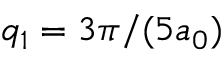Convert formula to latex. <formula><loc_0><loc_0><loc_500><loc_500>q _ { 1 } = 3 \pi / ( 5 a _ { 0 } )</formula> 